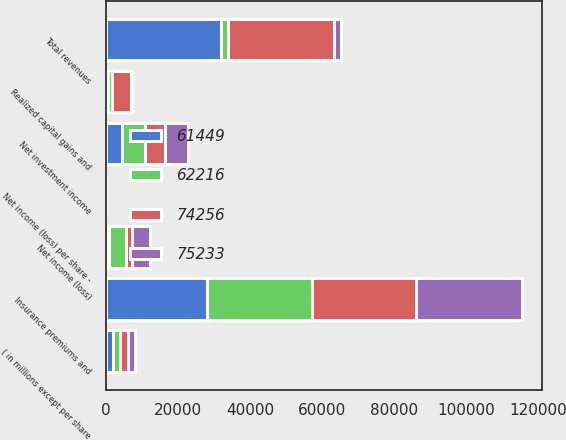Convert chart. <chart><loc_0><loc_0><loc_500><loc_500><stacked_bar_chart><ecel><fcel>( in millions except per share<fcel>Insurance premiums and<fcel>Net investment income<fcel>Realized capital gains and<fcel>Total revenues<fcel>Net income (loss)<fcel>Net income (loss) per share -<nl><fcel>61449<fcel>2009<fcel>28152<fcel>4444<fcel>583<fcel>32013<fcel>854<fcel>1.58<nl><fcel>74256<fcel>2008<fcel>28862<fcel>5622<fcel>5090<fcel>29394<fcel>1679<fcel>3.06<nl><fcel>62216<fcel>2007<fcel>29099<fcel>6435<fcel>1235<fcel>2007.5<fcel>4636<fcel>7.76<nl><fcel>75233<fcel>2006<fcel>29333<fcel>6177<fcel>286<fcel>2007.5<fcel>4993<fcel>7.83<nl></chart> 